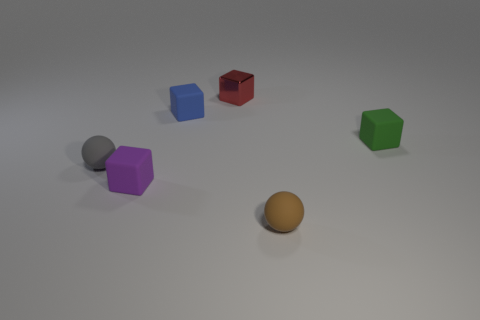Subtract 1 blocks. How many blocks are left? 3 Add 2 tiny purple matte blocks. How many objects exist? 8 Subtract all gray cubes. Subtract all gray spheres. How many cubes are left? 4 Subtract all blocks. How many objects are left? 2 Add 1 purple rubber objects. How many purple rubber objects exist? 2 Subtract 0 green cylinders. How many objects are left? 6 Subtract all tiny red matte cylinders. Subtract all tiny gray matte things. How many objects are left? 5 Add 6 small red objects. How many small red objects are left? 7 